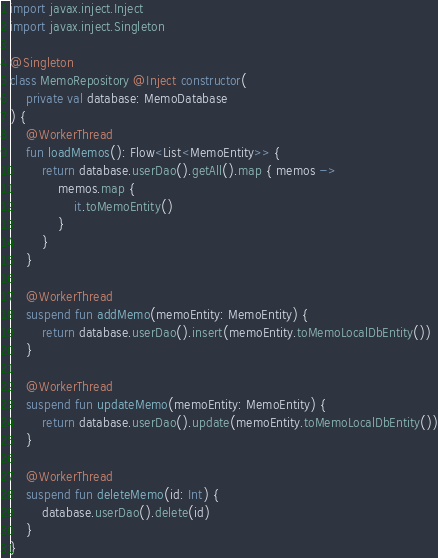<code> <loc_0><loc_0><loc_500><loc_500><_Kotlin_>import javax.inject.Inject
import javax.inject.Singleton

@Singleton
class MemoRepository @Inject constructor(
    private val database: MemoDatabase
) {
    @WorkerThread
    fun loadMemos(): Flow<List<MemoEntity>> {
        return database.userDao().getAll().map { memos ->
            memos.map {
                it.toMemoEntity()
            }
        }
    }

    @WorkerThread
    suspend fun addMemo(memoEntity: MemoEntity) {
        return database.userDao().insert(memoEntity.toMemoLocalDbEntity())
    }

    @WorkerThread
    suspend fun updateMemo(memoEntity: MemoEntity) {
        return database.userDao().update(memoEntity.toMemoLocalDbEntity())
    }

    @WorkerThread
    suspend fun deleteMemo(id: Int) {
        database.userDao().delete(id)
    }
}</code> 